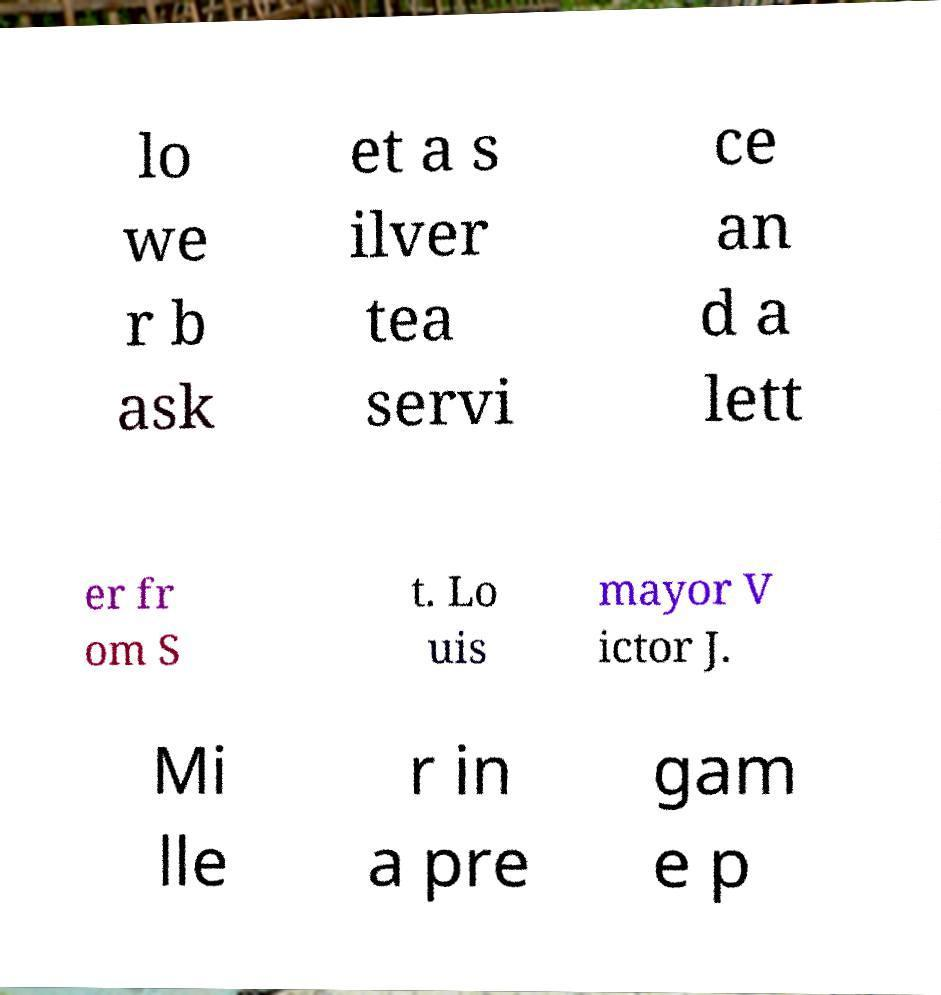Can you accurately transcribe the text from the provided image for me? lo we r b ask et a s ilver tea servi ce an d a lett er fr om S t. Lo uis mayor V ictor J. Mi lle r in a pre gam e p 